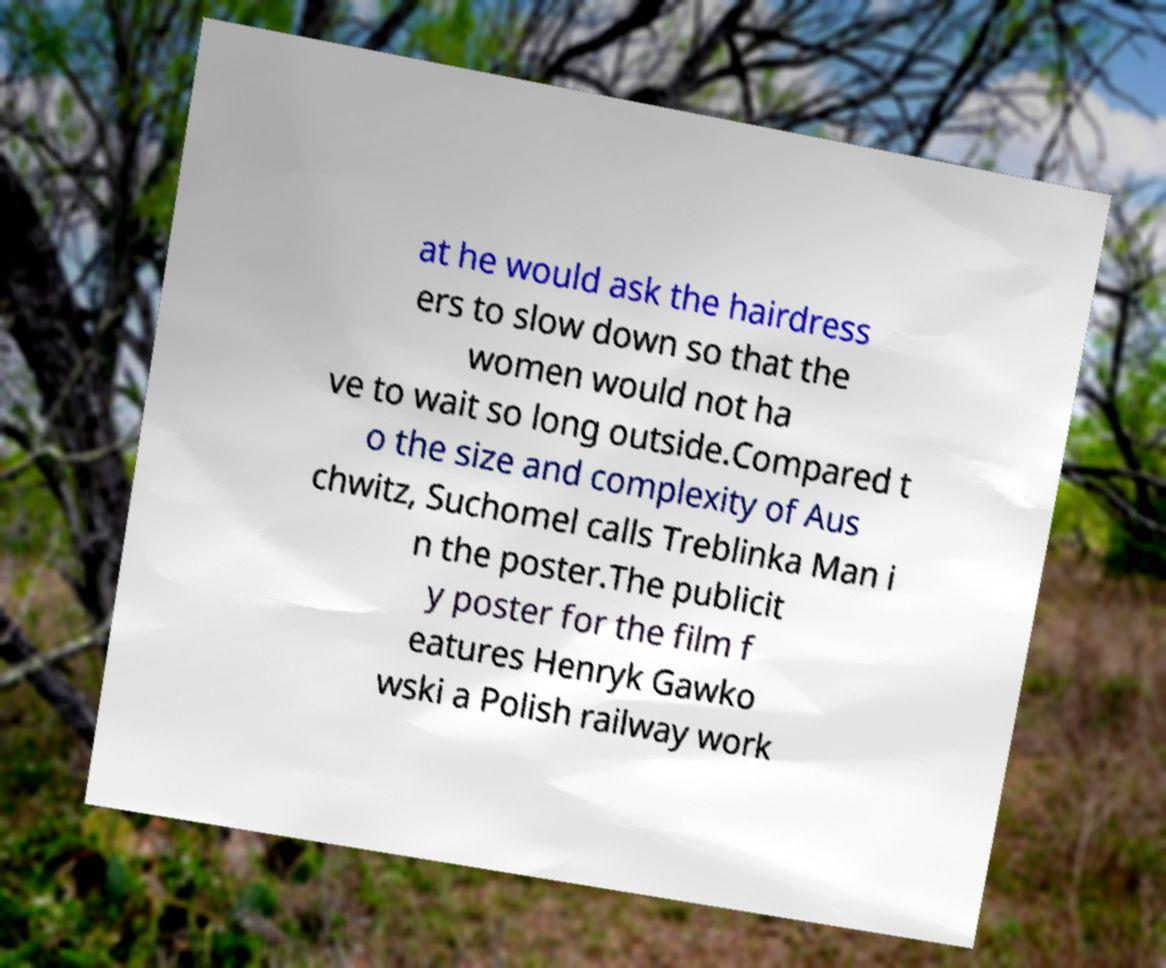Please identify and transcribe the text found in this image. at he would ask the hairdress ers to slow down so that the women would not ha ve to wait so long outside.Compared t o the size and complexity of Aus chwitz, Suchomel calls Treblinka Man i n the poster.The publicit y poster for the film f eatures Henryk Gawko wski a Polish railway work 